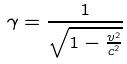Convert formula to latex. <formula><loc_0><loc_0><loc_500><loc_500>\gamma = \frac { 1 } { \sqrt { 1 - \frac { v ^ { 2 } } { c ^ { 2 } } } }</formula> 